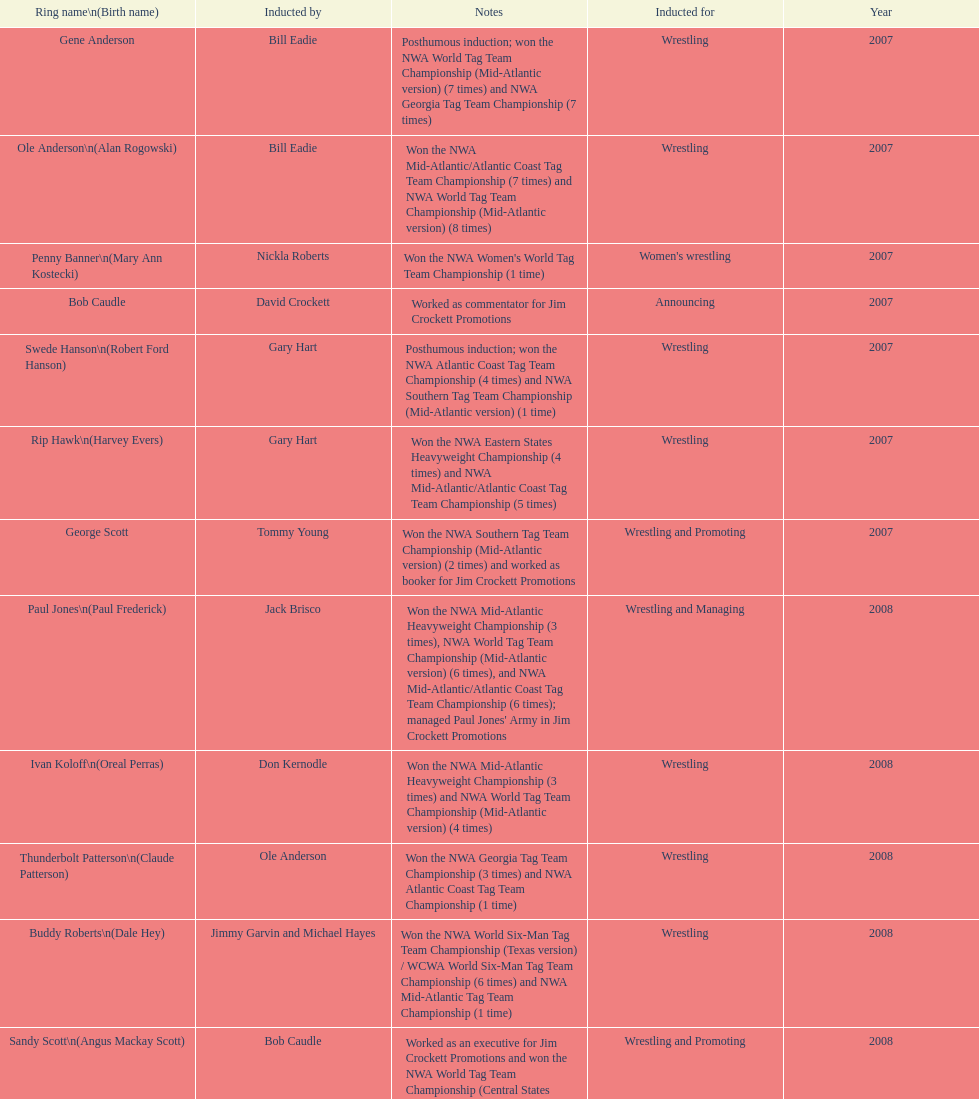Who was inducted after royal? Lance Russell. Would you mind parsing the complete table? {'header': ['Ring name\\n(Birth name)', 'Inducted by', 'Notes', 'Inducted for', 'Year'], 'rows': [['Gene Anderson', 'Bill Eadie', 'Posthumous induction; won the NWA World Tag Team Championship (Mid-Atlantic version) (7 times) and NWA Georgia Tag Team Championship (7 times)', 'Wrestling', '2007'], ['Ole Anderson\\n(Alan Rogowski)', 'Bill Eadie', 'Won the NWA Mid-Atlantic/Atlantic Coast Tag Team Championship (7 times) and NWA World Tag Team Championship (Mid-Atlantic version) (8 times)', 'Wrestling', '2007'], ['Penny Banner\\n(Mary Ann Kostecki)', 'Nickla Roberts', "Won the NWA Women's World Tag Team Championship (1 time)", "Women's wrestling", '2007'], ['Bob Caudle', 'David Crockett', 'Worked as commentator for Jim Crockett Promotions', 'Announcing', '2007'], ['Swede Hanson\\n(Robert Ford Hanson)', 'Gary Hart', 'Posthumous induction; won the NWA Atlantic Coast Tag Team Championship (4 times) and NWA Southern Tag Team Championship (Mid-Atlantic version) (1 time)', 'Wrestling', '2007'], ['Rip Hawk\\n(Harvey Evers)', 'Gary Hart', 'Won the NWA Eastern States Heavyweight Championship (4 times) and NWA Mid-Atlantic/Atlantic Coast Tag Team Championship (5 times)', 'Wrestling', '2007'], ['George Scott', 'Tommy Young', 'Won the NWA Southern Tag Team Championship (Mid-Atlantic version) (2 times) and worked as booker for Jim Crockett Promotions', 'Wrestling and Promoting', '2007'], ['Paul Jones\\n(Paul Frederick)', 'Jack Brisco', "Won the NWA Mid-Atlantic Heavyweight Championship (3 times), NWA World Tag Team Championship (Mid-Atlantic version) (6 times), and NWA Mid-Atlantic/Atlantic Coast Tag Team Championship (6 times); managed Paul Jones' Army in Jim Crockett Promotions", 'Wrestling and Managing', '2008'], ['Ivan Koloff\\n(Oreal Perras)', 'Don Kernodle', 'Won the NWA Mid-Atlantic Heavyweight Championship (3 times) and NWA World Tag Team Championship (Mid-Atlantic version) (4 times)', 'Wrestling', '2008'], ['Thunderbolt Patterson\\n(Claude Patterson)', 'Ole Anderson', 'Won the NWA Georgia Tag Team Championship (3 times) and NWA Atlantic Coast Tag Team Championship (1 time)', 'Wrestling', '2008'], ['Buddy Roberts\\n(Dale Hey)', 'Jimmy Garvin and Michael Hayes', 'Won the NWA World Six-Man Tag Team Championship (Texas version) / WCWA World Six-Man Tag Team Championship (6 times) and NWA Mid-Atlantic Tag Team Championship (1 time)', 'Wrestling', '2008'], ['Sandy Scott\\n(Angus Mackay Scott)', 'Bob Caudle', 'Worked as an executive for Jim Crockett Promotions and won the NWA World Tag Team Championship (Central States version) (1 time) and NWA Southern Tag Team Championship (Mid-Atlantic version) (3 times)', 'Wrestling and Promoting', '2008'], ['Grizzly Smith\\n(Aurelian Smith)', 'Magnum T.A.', 'Won the NWA United States Tag Team Championship (Tri-State version) (2 times) and NWA Texas Heavyweight Championship (1 time)', 'Wrestling', '2008'], ['Johnny Weaver\\n(Kenneth Eugene Weaver)', 'Rip Hawk', 'Posthumous induction; won the NWA Atlantic Coast/Mid-Atlantic Tag Team Championship (8 times) and NWA Southern Tag Team Championship (Mid-Atlantic version) (6 times)', 'Wrestling', '2008'], ['Don Fargo\\n(Don Kalt)', 'Jerry Jarrett & Steve Keirn', 'Won the NWA Southern Tag Team Championship (Mid-America version) (2 times) and NWA World Tag Team Championship (Mid-America version) (6 times)', 'Wrestling', '2009'], ['Jackie Fargo\\n(Henry Faggart)', 'Jerry Jarrett & Steve Keirn', 'Won the NWA World Tag Team Championship (Mid-America version) (10 times) and NWA Southern Tag Team Championship (Mid-America version) (22 times)', 'Wrestling', '2009'], ['Sonny Fargo\\n(Jack Lewis Faggart)', 'Jerry Jarrett & Steve Keirn', 'Posthumous induction; won the NWA Southern Tag Team Championship (Mid-America version) (3 times)', 'Wrestling', '2009'], ['Gary Hart\\n(Gary Williams)', 'Sir Oliver Humperdink', 'Posthumous induction; worked as a booker in World Class Championship Wrestling and managed several wrestlers in Mid-Atlantic Championship Wrestling', 'Managing and Promoting', '2009'], ['Wahoo McDaniel\\n(Edward McDaniel)', 'Tully Blanchard', 'Posthumous induction; won the NWA Mid-Atlantic Heavyweight Championship (6 times) and NWA World Tag Team Championship (Mid-Atlantic version) (4 times)', 'Wrestling', '2009'], ['Blackjack Mulligan\\n(Robert Windham)', 'Ric Flair', 'Won the NWA Texas Heavyweight Championship (1 time) and NWA World Tag Team Championship (Mid-Atlantic version) (1 time)', 'Wrestling', '2009'], ['Nelson Royal', 'Brad Anderson, Tommy Angel & David Isley', 'Won the NWA Atlantic Coast Tag Team Championship (2 times)', 'Wrestling', '2009'], ['Lance Russell', 'Dave Brown', 'Worked as commentator for wrestling events in the Memphis area', 'Announcing', '2009']]} 